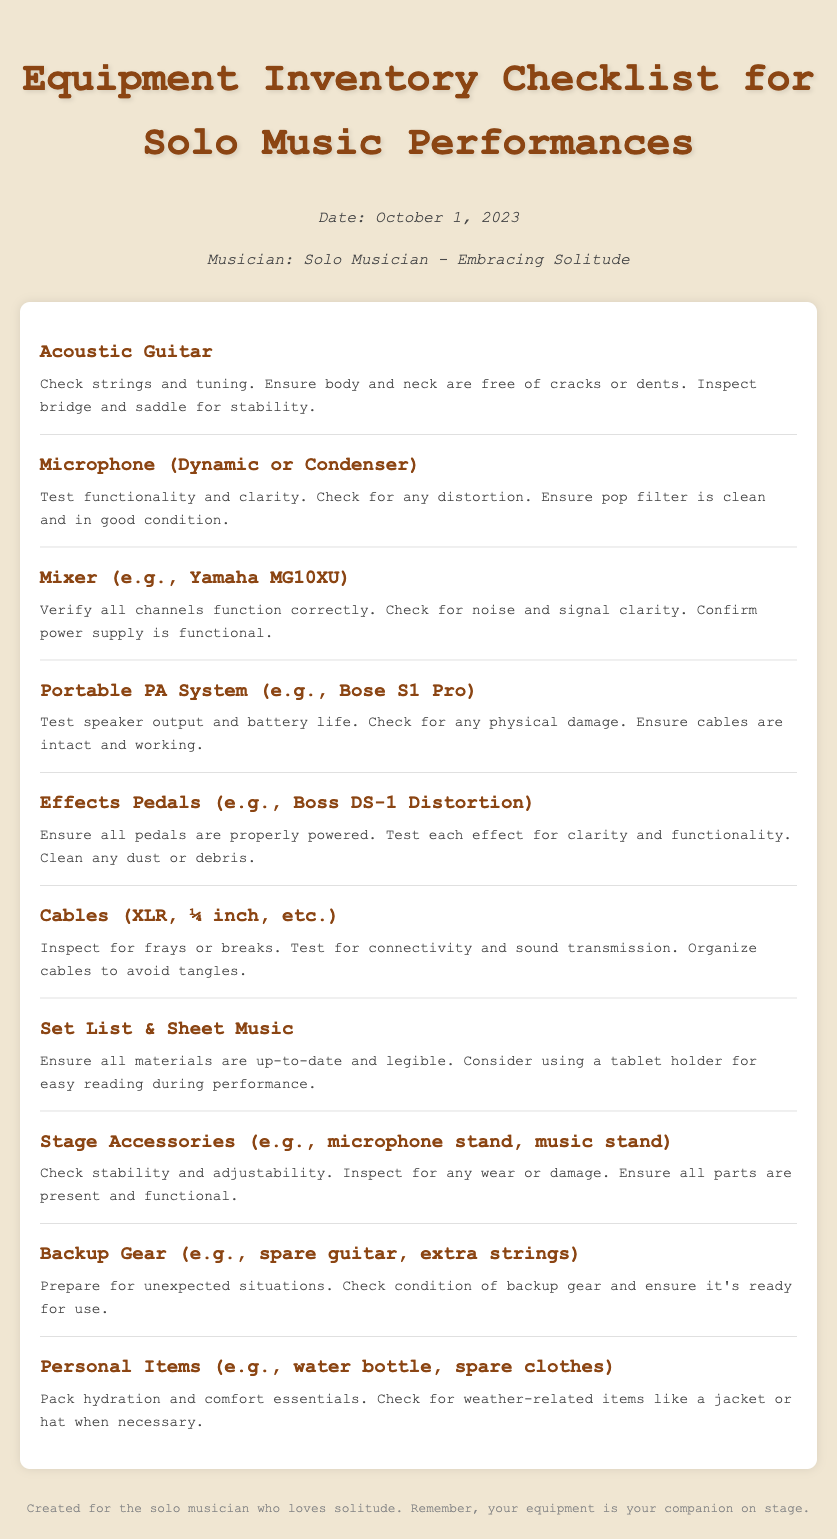What is the title of the document? The title of the document is indicated at the top.
Answer: Equipment Inventory Checklist for Solo Music Performances Who is the musician mentioned in the document? The document specifies the musician's persona in the header info section.
Answer: Solo Musician - Embracing Solitude What is included in the checklist for condition notes? Each checklist item has a description of its condition notes underneath its name.
Answer: Acoustic Guitar, Microphone, Mixer, Portable PA System, Effects Pedals, Cables, Set List & Sheet Music, Stage Accessories, Backup Gear, Personal Items What is the date of the checklist? The date is listed in the header section of the document.
Answer: October 1, 2023 Which item should you test for clarity and functionality among the effects? It refers to assessing functionality for one specific item in the checklist.
Answer: Effects Pedals How many items are listed in the checklist? The number of checklist items can be counted from the entries provided.
Answer: 10 What should you inspect cables for? The condition notes for cables mention specific issues to look for.
Answer: Frays or breaks What type of personal items should a musician pack? The personal items section specifies what should be included for comfort.
Answer: Hydration and comfort essentials Why is backup gear important? The condition notes explain the purpose of having backup gear ready.
Answer: Prepare for unexpected situations 